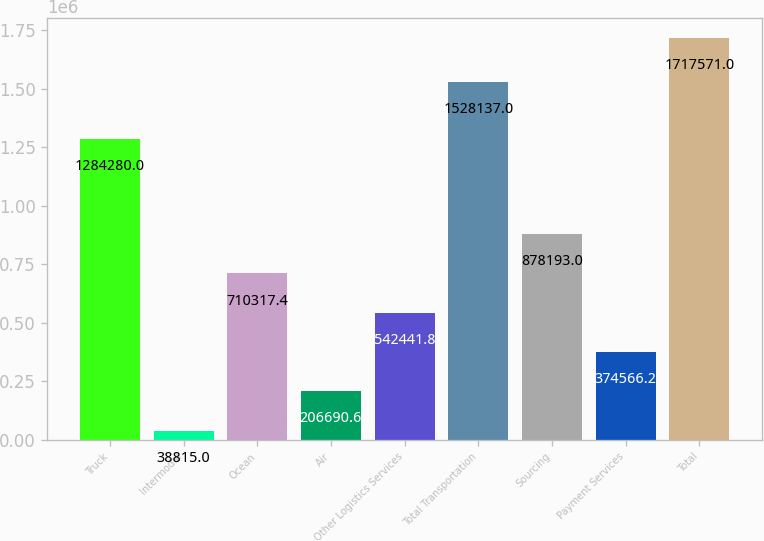<chart> <loc_0><loc_0><loc_500><loc_500><bar_chart><fcel>Truck<fcel>Intermodal<fcel>Ocean<fcel>Air<fcel>Other Logistics Services<fcel>Total Transportation<fcel>Sourcing<fcel>Payment Services<fcel>Total<nl><fcel>1.28428e+06<fcel>38815<fcel>710317<fcel>206691<fcel>542442<fcel>1.52814e+06<fcel>878193<fcel>374566<fcel>1.71757e+06<nl></chart> 